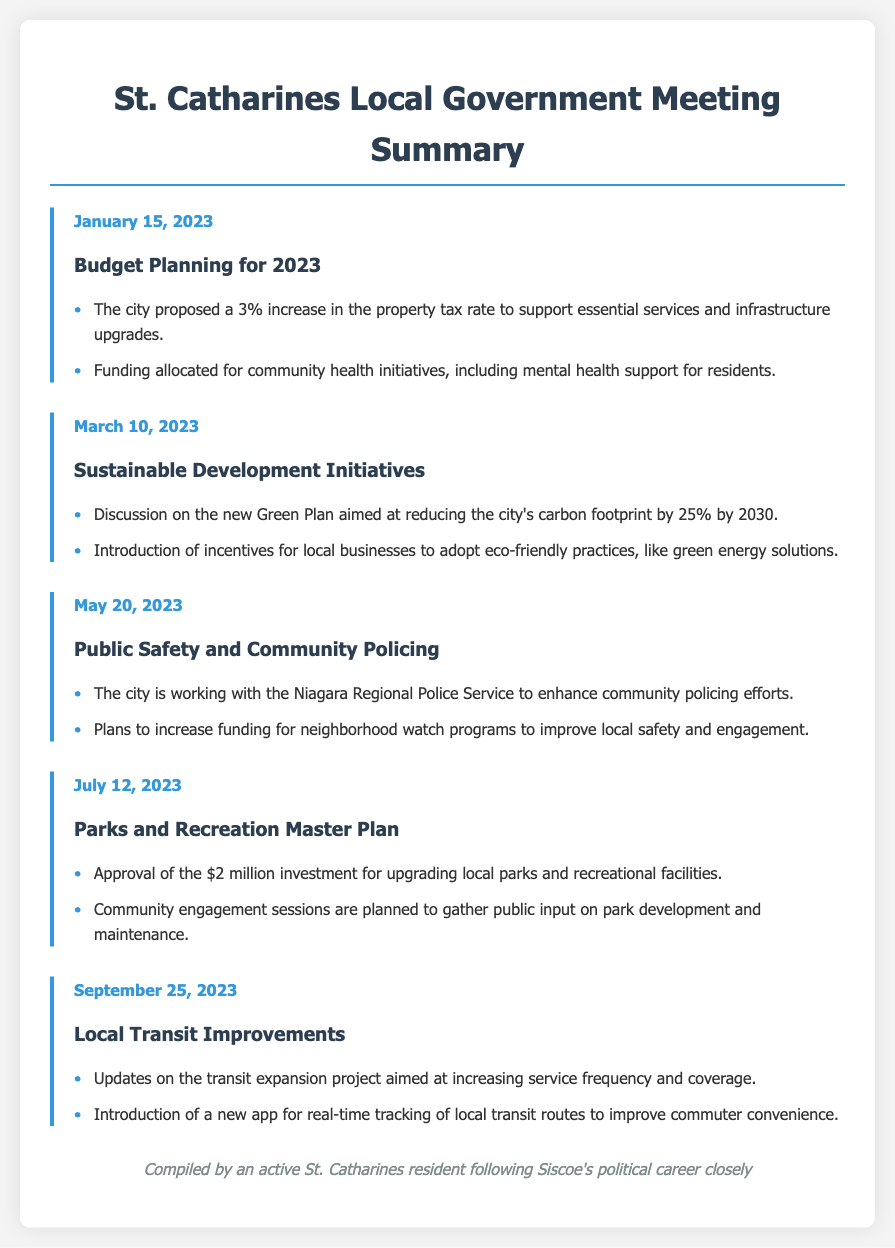What was the proposed increase in property tax rate for 2023? The document states that the city proposed a 3% increase in the property tax rate.
Answer: 3% What major initiative aims to reduce the city's carbon footprint? The document discusses a new Green Plan aimed at reducing the city's carbon footprint by 25% by 2030.
Answer: Green Plan When was the meeting focused on Parks and Recreation Master Plan held? The date of the meeting regarding the Parks and Recreation Master Plan is mentioned in the document as July 12, 2023.
Answer: July 12, 2023 How much is being invested in upgrading local parks? The document specifies that there is a $2 million investment for upgrading local parks and recreational facilities.
Answer: $2 million What is the main goal of the local transit improvements discussed? The focus of the local transit improvements is to increase service frequency and coverage.
Answer: Increase service frequency and coverage How is the city enhancing community policing efforts? The document notes that the city is working with the Niagara Regional Police Service to enhance community policing efforts.
Answer: Niagara Regional Police Service Which organization is mentioned in relation to neighborhood watch programs? The document mentions plans to increase funding for neighborhood watch programs, indicating a collaboration aspect.
Answer: Neighborhood watch programs What is planned for gathering public input on park development? The document states that community engagement sessions are planned to gather public input on park development and maintenance.
Answer: Community engagement sessions 